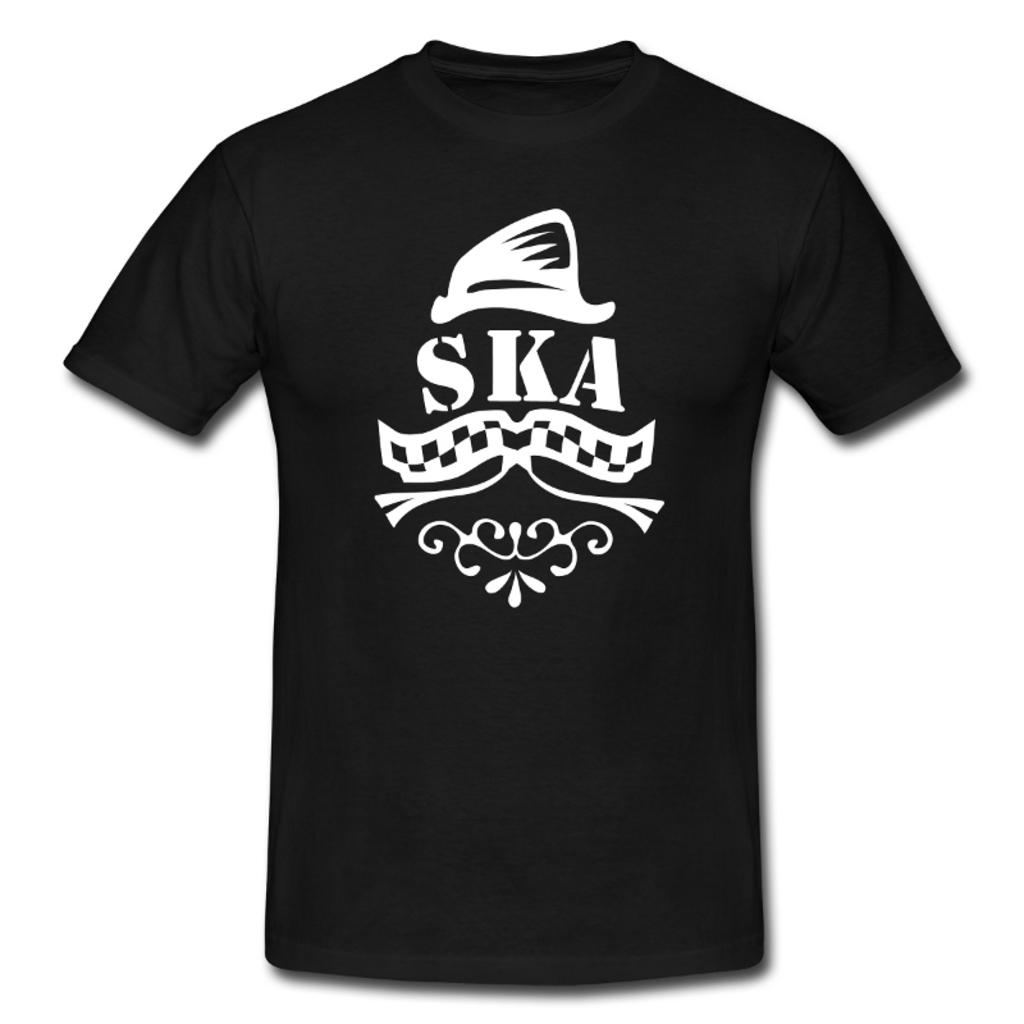What color is the t-shirt in the image? The t-shirt in the image is black in color. What is the color of the background in the image? The background of the image is white in color. What type of drug is being advertised on the calendar in the image? There is no calendar or drug present in the image. 